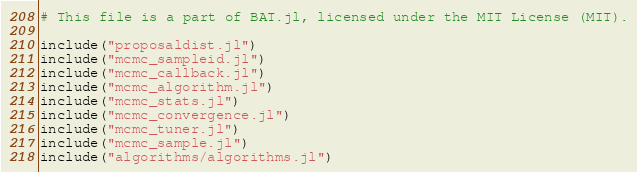<code> <loc_0><loc_0><loc_500><loc_500><_Julia_># This file is a part of BAT.jl, licensed under the MIT License (MIT).

include("proposaldist.jl")
include("mcmc_sampleid.jl")
include("mcmc_callback.jl")
include("mcmc_algorithm.jl")
include("mcmc_stats.jl")
include("mcmc_convergence.jl")
include("mcmc_tuner.jl")
include("mcmc_sample.jl")
include("algorithms/algorithms.jl")
</code> 